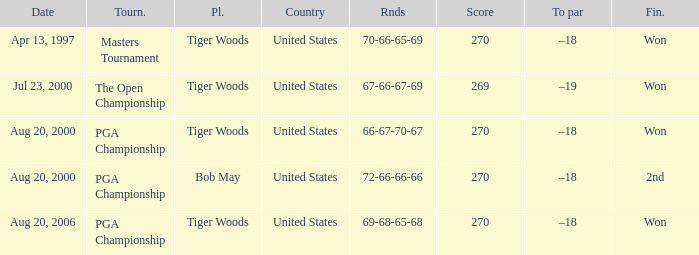What days were the rounds of 66-67-70-67 recorded? Aug 20, 2000. 